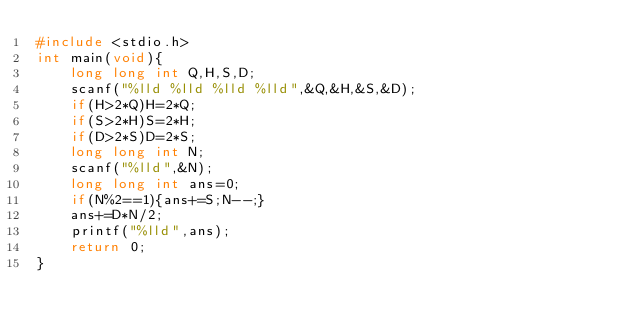Convert code to text. <code><loc_0><loc_0><loc_500><loc_500><_C_>#include <stdio.h>
int main(void){
    long long int Q,H,S,D;
    scanf("%lld %lld %lld %lld",&Q,&H,&S,&D);
    if(H>2*Q)H=2*Q;
    if(S>2*H)S=2*H;
    if(D>2*S)D=2*S;
    long long int N;
    scanf("%lld",&N);
    long long int ans=0;
    if(N%2==1){ans+=S;N--;}
    ans+=D*N/2;
    printf("%lld",ans);
    return 0;
}
</code> 